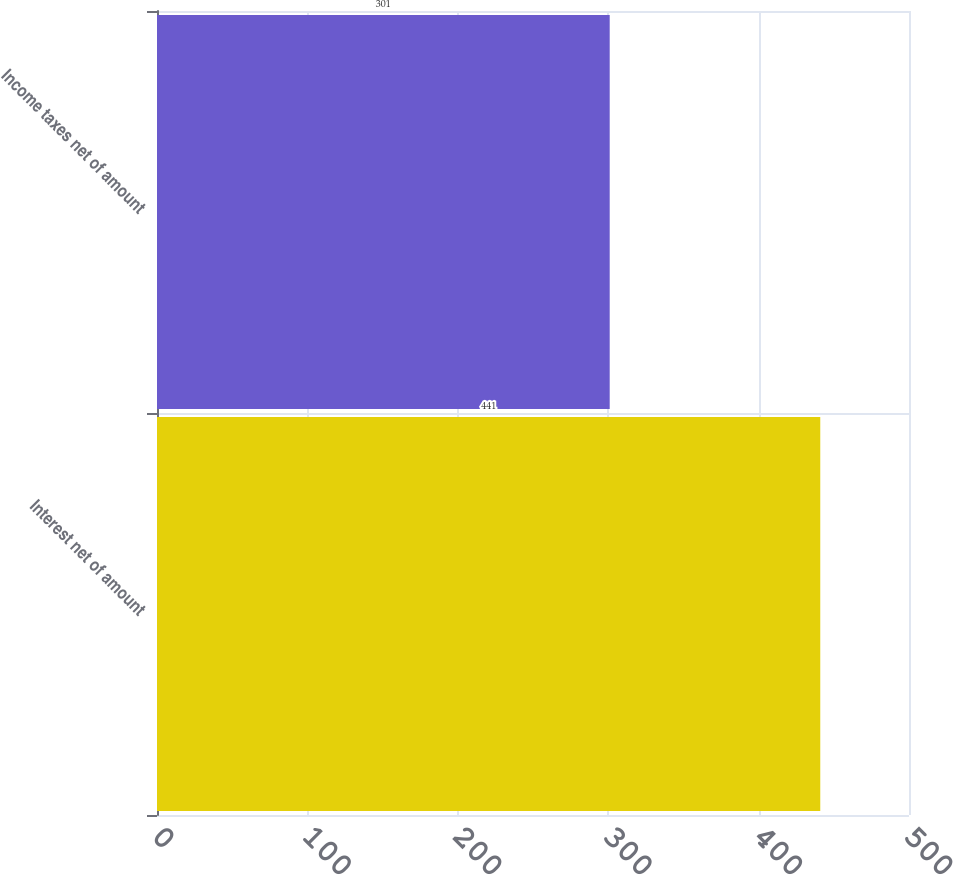Convert chart. <chart><loc_0><loc_0><loc_500><loc_500><bar_chart><fcel>Interest net of amount<fcel>Income taxes net of amount<nl><fcel>441<fcel>301<nl></chart> 